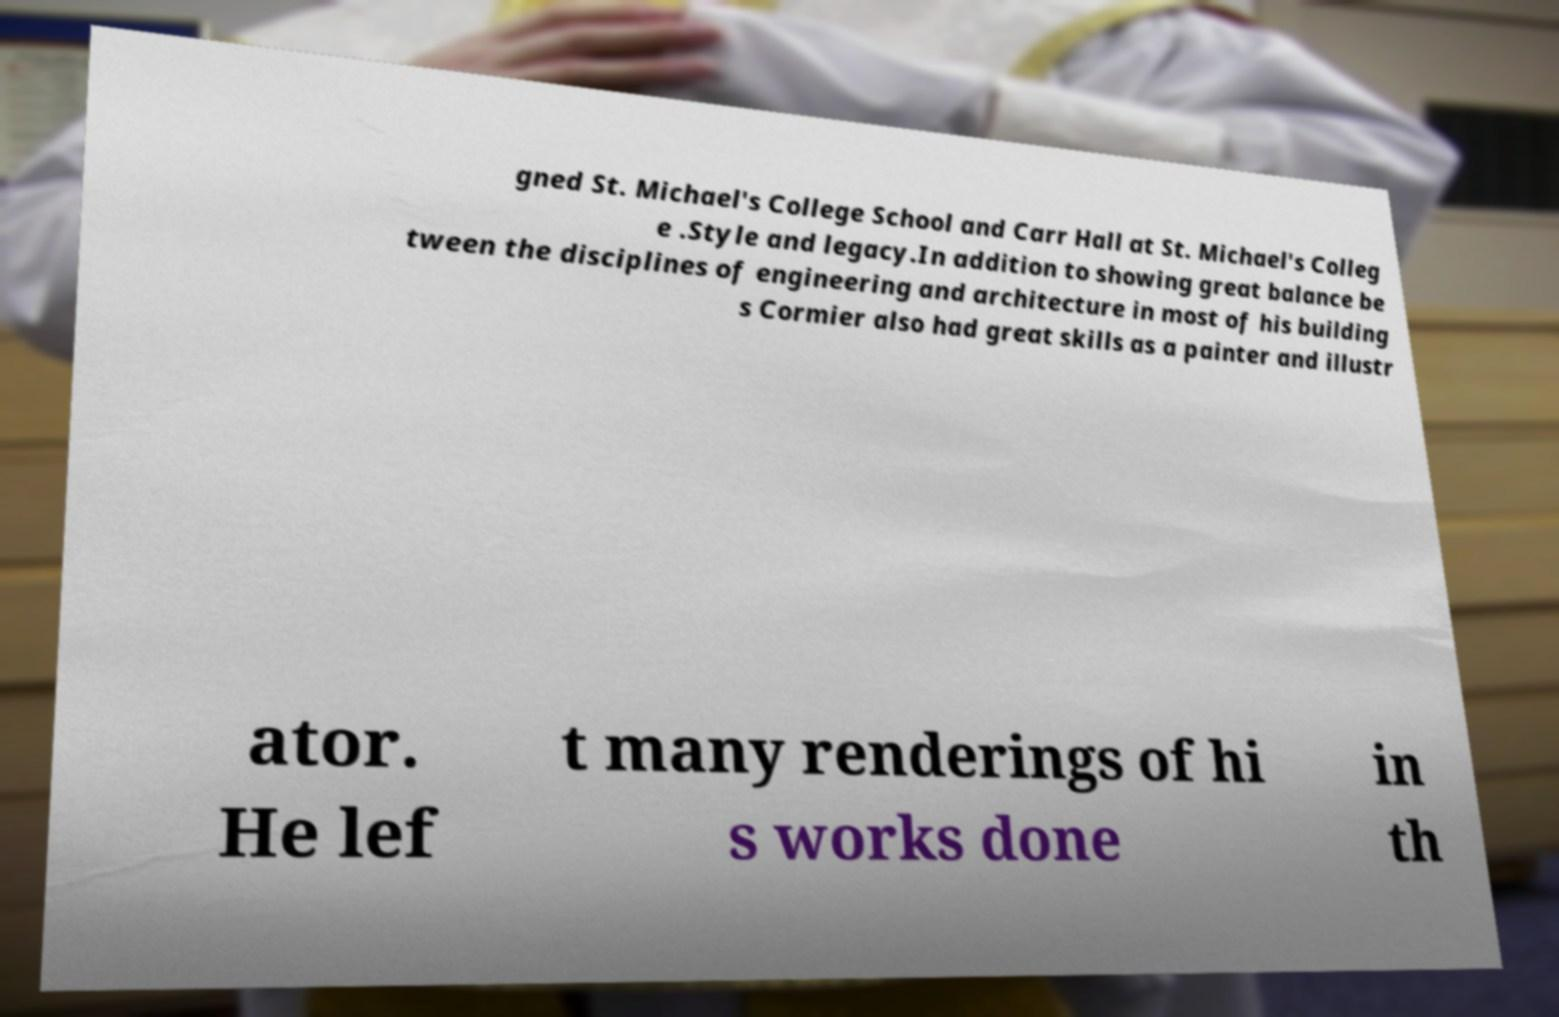Please identify and transcribe the text found in this image. gned St. Michael's College School and Carr Hall at St. Michael's Colleg e .Style and legacy.In addition to showing great balance be tween the disciplines of engineering and architecture in most of his building s Cormier also had great skills as a painter and illustr ator. He lef t many renderings of hi s works done in th 